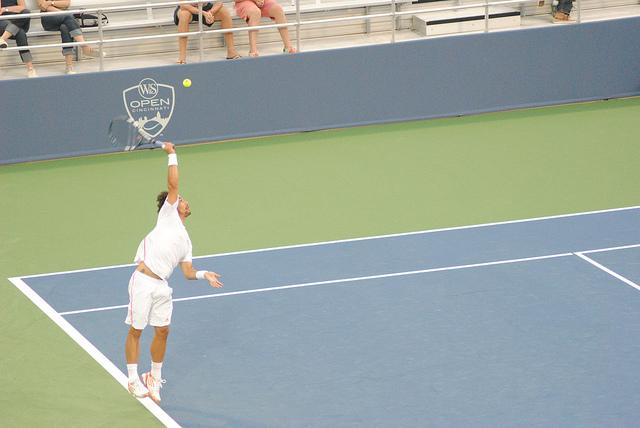What does the W S stand for?

Choices:
A) washington/state
B) white/scarlet
C) world/sport
D) western/southern western/southern 